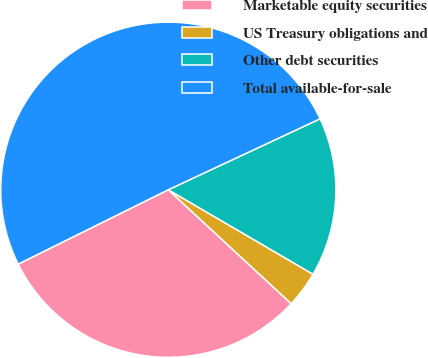<chart> <loc_0><loc_0><loc_500><loc_500><pie_chart><fcel>Marketable equity securities<fcel>US Treasury obligations and<fcel>Other debt securities<fcel>Total available-for-sale<nl><fcel>30.78%<fcel>3.49%<fcel>15.37%<fcel>50.36%<nl></chart> 